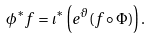<formula> <loc_0><loc_0><loc_500><loc_500>\phi ^ { * } f = \iota ^ { * } \left ( e ^ { \vartheta } ( f \circ \Phi ) \right ) .</formula> 